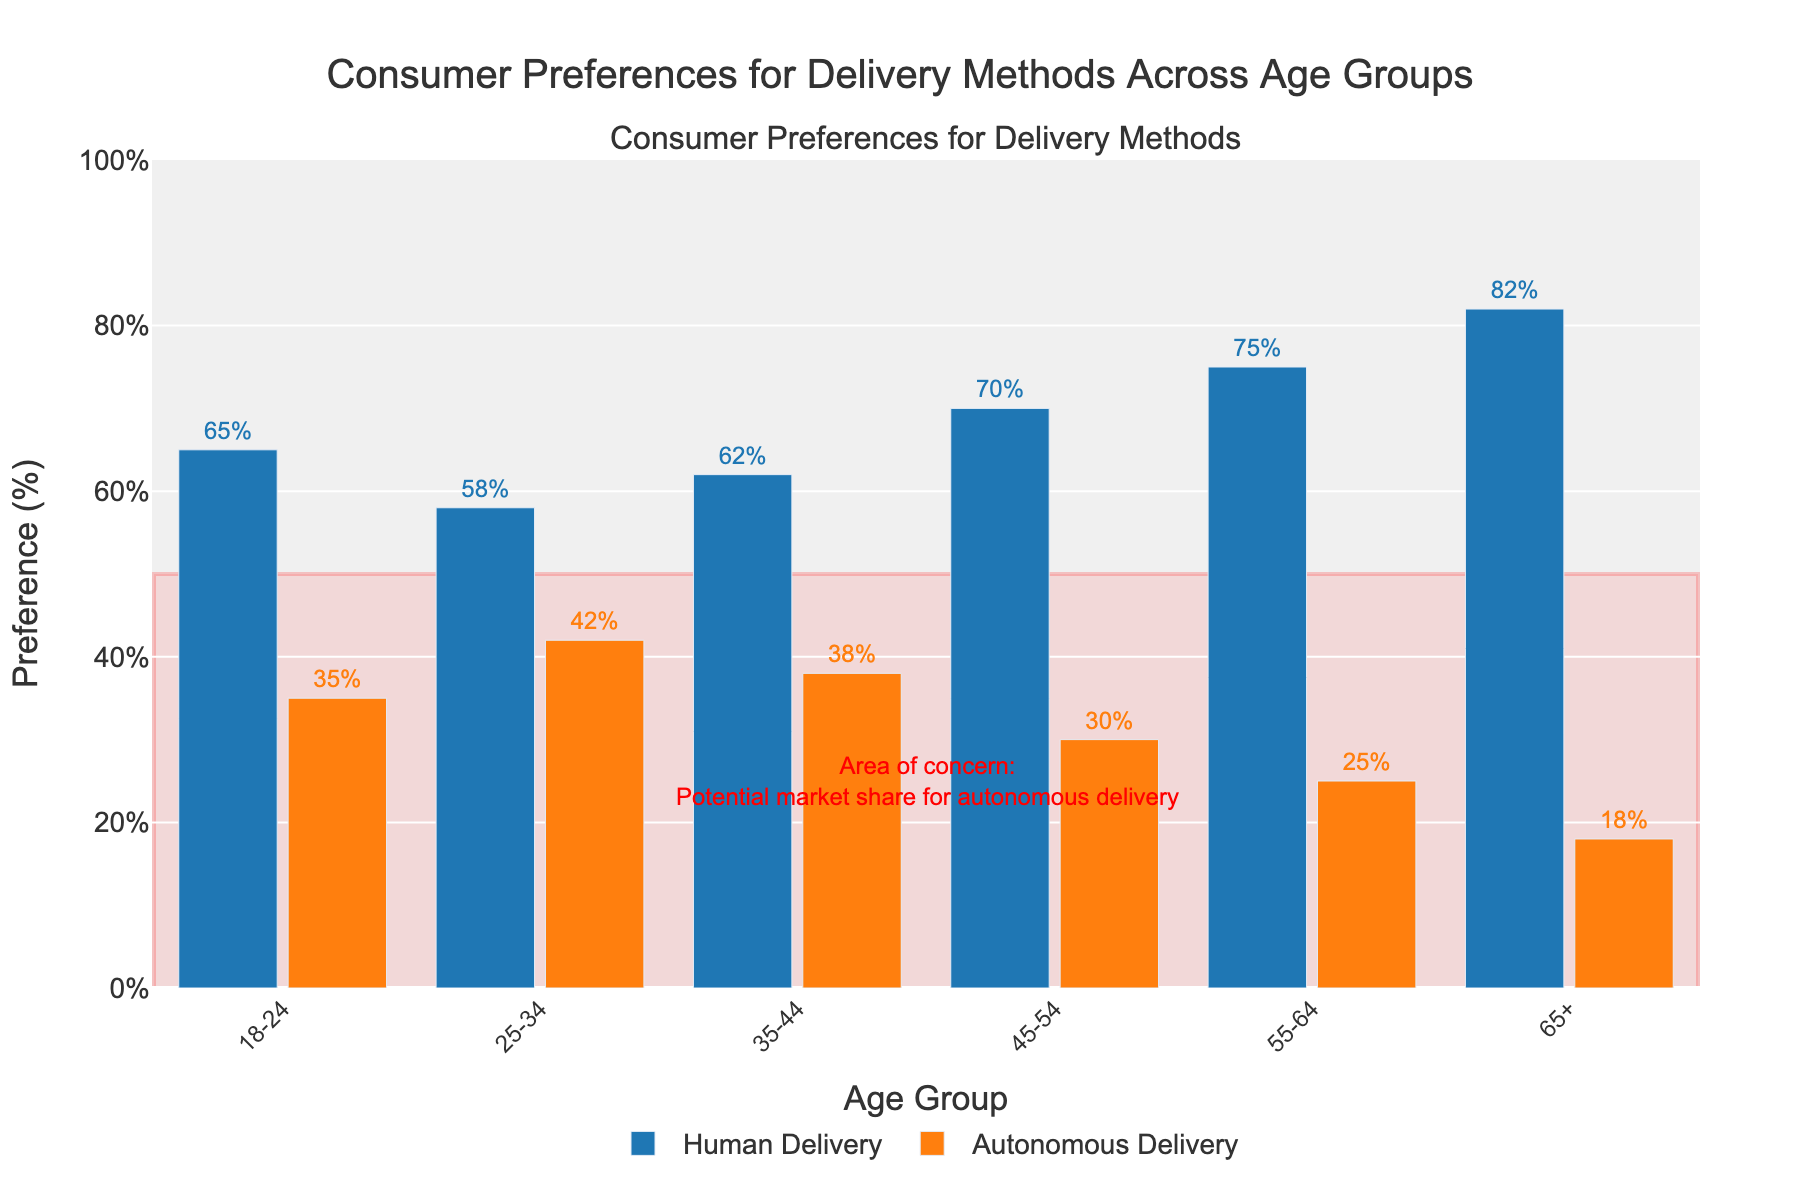What percentage of the 18-24 age group prefers human delivery? To find the percentage of the 18-24 age group that prefers human delivery, locate the bar corresponding to human delivery in the 18-24 age group. The label on the bar shows 65%.
Answer: 65% Which age group has the highest preference for autonomous delivery? Compare the heights of the orange bars (representing autonomous delivery) for each age group. The 25-34 age group has the tallest orange bar, which means it has the highest preference for autonomous delivery at 42%.
Answer: 25-34 What is the difference in preference for human delivery between the 55-64 age group and the 65+ age group? Locate the bars for human delivery in both the 55-64 and 65+ age groups. The 55-64 age group prefers human delivery by 75%, and the 65+ age group by 82%. The difference is 82% - 75% = 7%.
Answer: 7% How does the preference for autonomous delivery change as the age group increases from 18-24 to 65+? Observe the heights of the orange bars (autonomous delivery) from the youngest to oldest age groups. The preferences decrease from 35%, 42%, 38%, 30%, 25%, to 18% respectively. Thus, there is a general decreasing trend as age increases.
Answer: Decreases In which age group is the difference between preferences for human and autonomous delivery the greatest? Calculate the difference for each age group by subtracting the autonomous delivery percentage from the human delivery percentage. The differences are: 18-24 (65%-35%=30%), 25-34 (58%-42%=16%), 35-44 (62%-38%=24%), 45-54 (70%-30%=40%), 55-64 (75%-25%=50%), 65+ (82%-18%=64%). The greatest difference occurs in the 65+ age group, at 64%.
Answer: 65+ Which age groups have a higher preference for human delivery than the mean preference for human delivery across all age groups? First, calculate the mean preference for human delivery across all age groups: (65% + 58% + 62% + 70% + 75% + 82%) / 6 = 68.67%. Compare each age group's preference for human delivery against the mean. The age groups are 45-54 (70%), 55-64 (75%), and 65+ (82%) which are higher than 68.67%.
Answer: 45-54, 55-64, 65+ What is the combined preference for human delivery for age groups 35-44 and 45-54? Sum the preferences for human delivery for the 35-44 (62%) and 45-54 (70%) age groups. The total is 62% + 70% = 132%.
Answer: 132% Which color represents the preference for autonomous delivery in the plot? Identify the color of the bars representing autonomous delivery in the plot. These bars are orange.
Answer: Orange 